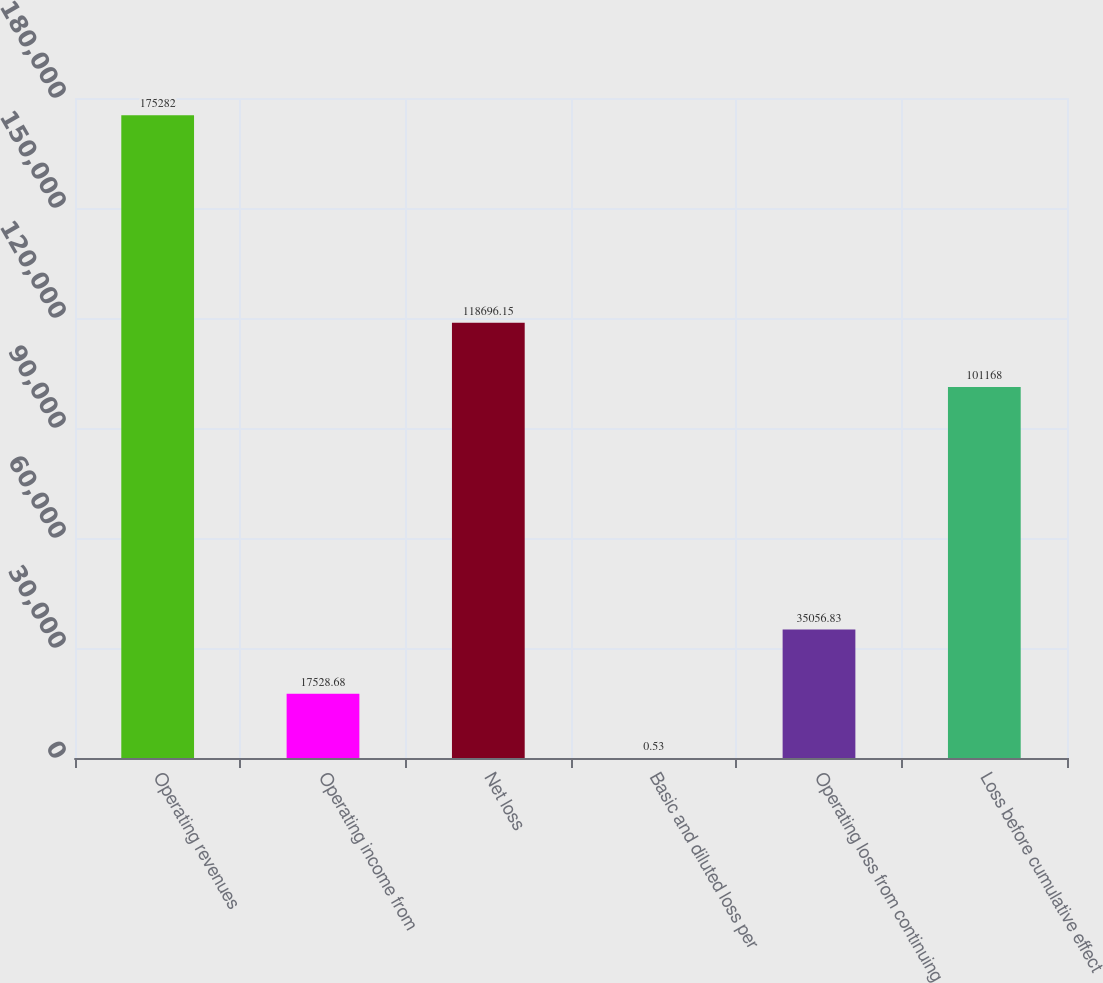Convert chart. <chart><loc_0><loc_0><loc_500><loc_500><bar_chart><fcel>Operating revenues<fcel>Operating income from<fcel>Net loss<fcel>Basic and diluted loss per<fcel>Operating loss from continuing<fcel>Loss before cumulative effect<nl><fcel>175282<fcel>17528.7<fcel>118696<fcel>0.53<fcel>35056.8<fcel>101168<nl></chart> 